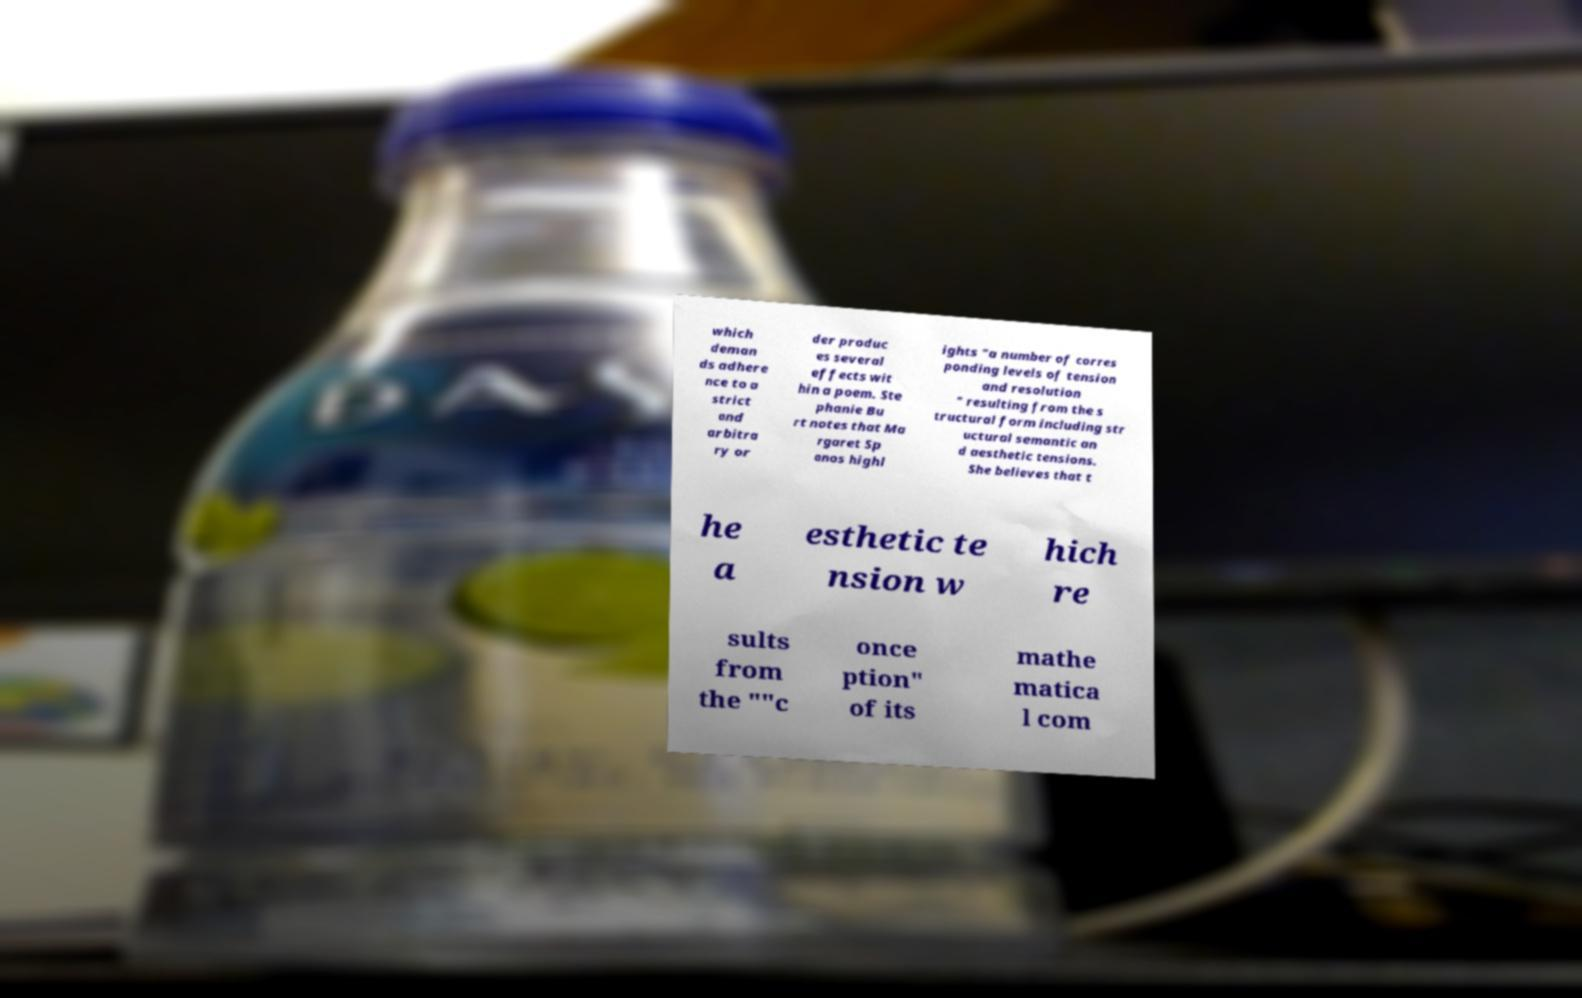Please read and relay the text visible in this image. What does it say? which deman ds adhere nce to a strict and arbitra ry or der produc es several effects wit hin a poem. Ste phanie Bu rt notes that Ma rgaret Sp anos highl ights "a number of corres ponding levels of tension and resolution " resulting from the s tructural form including str uctural semantic an d aesthetic tensions. She believes that t he a esthetic te nsion w hich re sults from the ""c once ption" of its mathe matica l com 